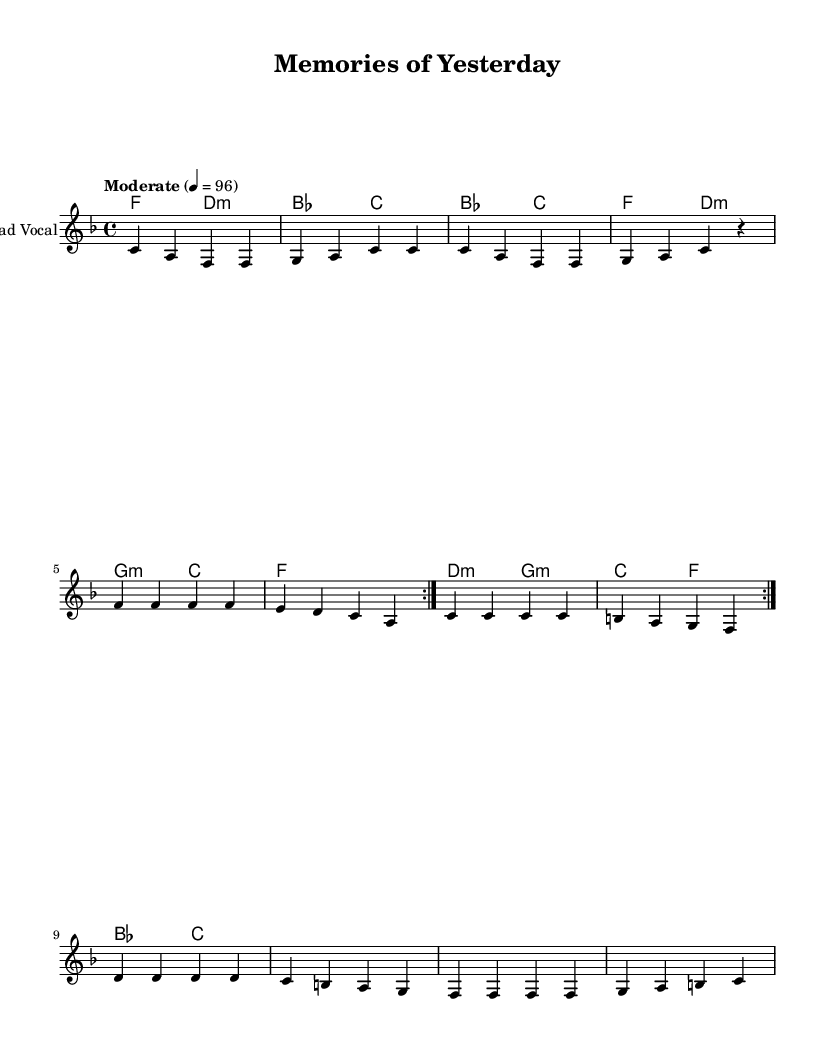What is the key signature of this music? The key signature shows one flat, indicating it is in the key of F major.
Answer: F major What is the time signature of this music? The time signature shown at the beginning of the sheet music is 4/4, meaning there are four beats per measure and the quarter note gets one beat.
Answer: 4/4 What is the tempo of this piece? The tempo marking in the music indicates "Moderate" with a metronome marking of 96 beats per minute, which guides the performer on the speed of the music.
Answer: 96 How many verses does the melody contain? By analyzing the repeated structure and the indication of lyrics, it is clear that the melody contains two sections that repeat, suggesting there are two verses based on this structure.
Answer: 2 What chord follows the first G minor chord? The chord progression shows that after the G minor chord, the next chord presented is a C major chord, following the traditional harmonic movement.
Answer: C What is the starting note of the melody? The melody begins with the note C, which is indicated at the beginning of the first measure.
Answer: C What type of song structure is evident in this piece? The structure indicated includes a verse and chorus section with a bridge, which is typical for Rhythm and blues songs, allowing for both melodic and lyrical variation.
Answer: Verse and chorus structure 